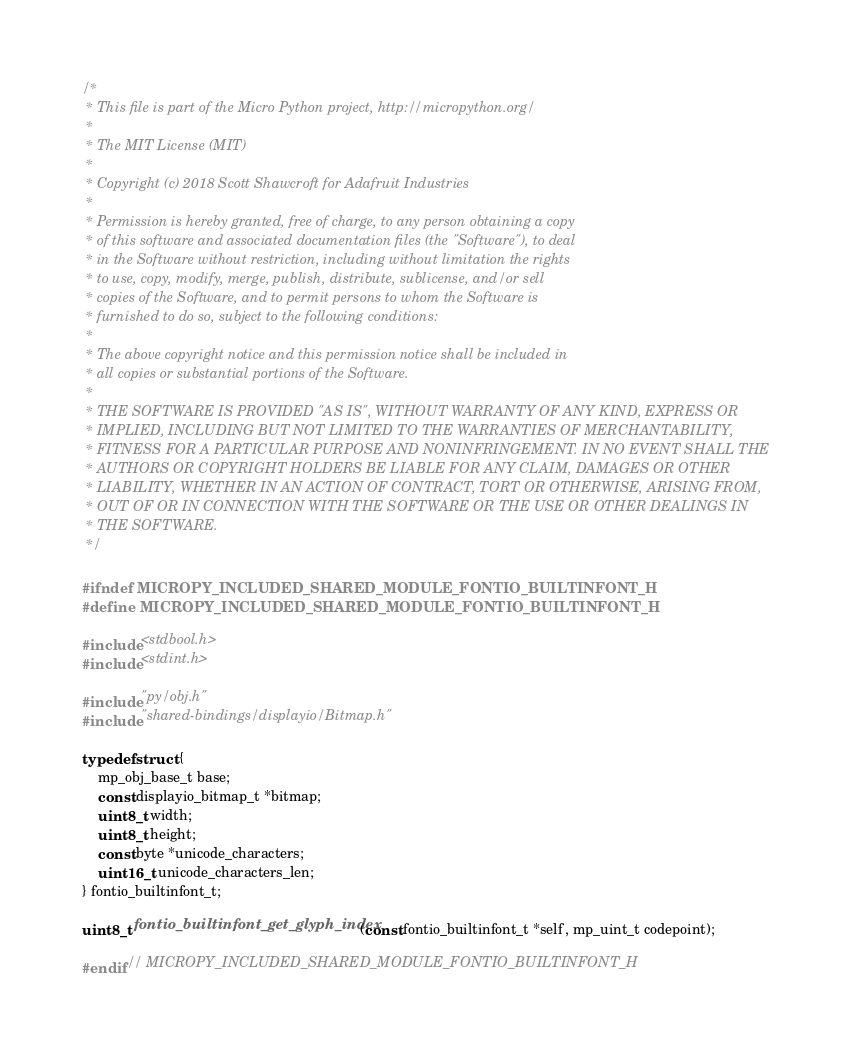<code> <loc_0><loc_0><loc_500><loc_500><_C_>/*
 * This file is part of the Micro Python project, http://micropython.org/
 *
 * The MIT License (MIT)
 *
 * Copyright (c) 2018 Scott Shawcroft for Adafruit Industries
 *
 * Permission is hereby granted, free of charge, to any person obtaining a copy
 * of this software and associated documentation files (the "Software"), to deal
 * in the Software without restriction, including without limitation the rights
 * to use, copy, modify, merge, publish, distribute, sublicense, and/or sell
 * copies of the Software, and to permit persons to whom the Software is
 * furnished to do so, subject to the following conditions:
 *
 * The above copyright notice and this permission notice shall be included in
 * all copies or substantial portions of the Software.
 *
 * THE SOFTWARE IS PROVIDED "AS IS", WITHOUT WARRANTY OF ANY KIND, EXPRESS OR
 * IMPLIED, INCLUDING BUT NOT LIMITED TO THE WARRANTIES OF MERCHANTABILITY,
 * FITNESS FOR A PARTICULAR PURPOSE AND NONINFRINGEMENT. IN NO EVENT SHALL THE
 * AUTHORS OR COPYRIGHT HOLDERS BE LIABLE FOR ANY CLAIM, DAMAGES OR OTHER
 * LIABILITY, WHETHER IN AN ACTION OF CONTRACT, TORT OR OTHERWISE, ARISING FROM,
 * OUT OF OR IN CONNECTION WITH THE SOFTWARE OR THE USE OR OTHER DEALINGS IN
 * THE SOFTWARE.
 */

#ifndef MICROPY_INCLUDED_SHARED_MODULE_FONTIO_BUILTINFONT_H
#define MICROPY_INCLUDED_SHARED_MODULE_FONTIO_BUILTINFONT_H

#include <stdbool.h>
#include <stdint.h>

#include "py/obj.h"
#include "shared-bindings/displayio/Bitmap.h"

typedef struct {
    mp_obj_base_t base;
    const displayio_bitmap_t *bitmap;
    uint8_t width;
    uint8_t height;
    const byte *unicode_characters;
    uint16_t unicode_characters_len;
} fontio_builtinfont_t;

uint8_t fontio_builtinfont_get_glyph_index(const fontio_builtinfont_t *self, mp_uint_t codepoint);

#endif // MICROPY_INCLUDED_SHARED_MODULE_FONTIO_BUILTINFONT_H
</code> 